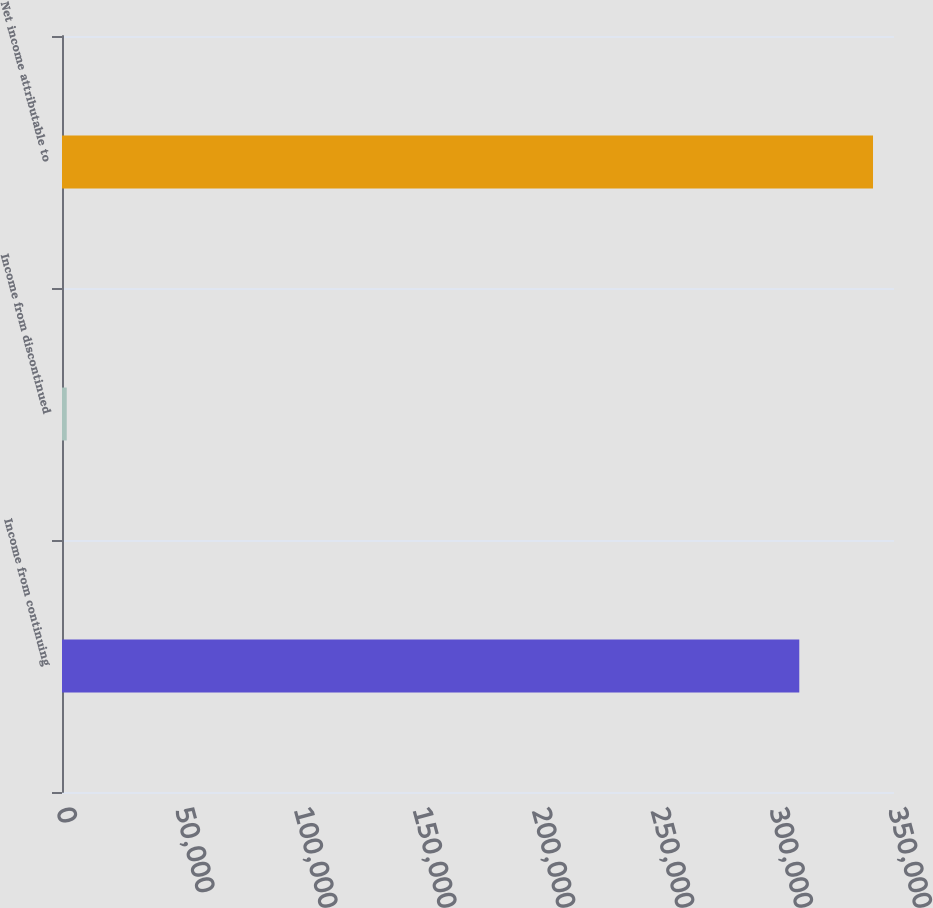<chart> <loc_0><loc_0><loc_500><loc_500><bar_chart><fcel>Income from continuing<fcel>Income from discontinued<fcel>Net income attributable to<nl><fcel>310156<fcel>1987<fcel>341172<nl></chart> 